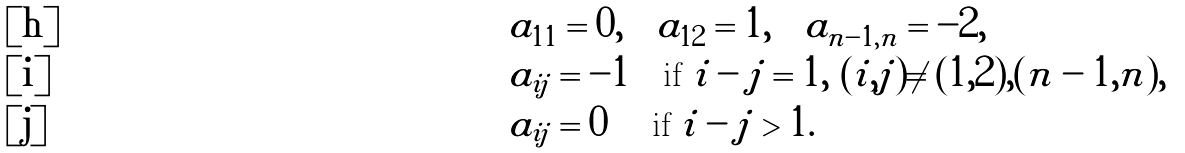<formula> <loc_0><loc_0><loc_500><loc_500>\, & a _ { 1 1 } = 0 , \quad a _ { 1 2 } = 1 , \quad a _ { n - 1 , n } = - 2 , \\ \, & a _ { i j } = - 1 \quad \text {if} \ | i - j | = 1 , \ ( i , j ) \neq ( 1 , 2 ) , ( n - 1 , n ) , \\ \, & a _ { i j } = 0 \quad \ \text {if} \ | i - j | > 1 .</formula> 